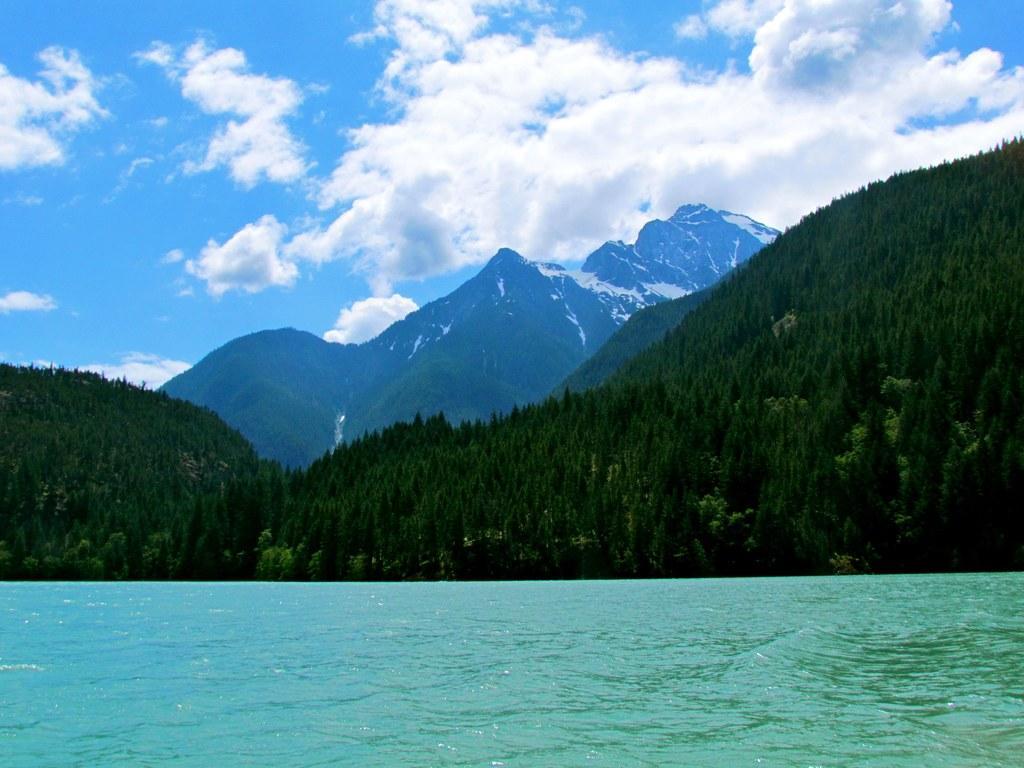How would you summarize this image in a sentence or two? In this picture we can see some greenery and few mountains in the background. We can see water. Sky is blue in color and cloudy. 